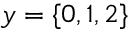<formula> <loc_0><loc_0><loc_500><loc_500>y = \{ 0 , 1 , 2 \}</formula> 